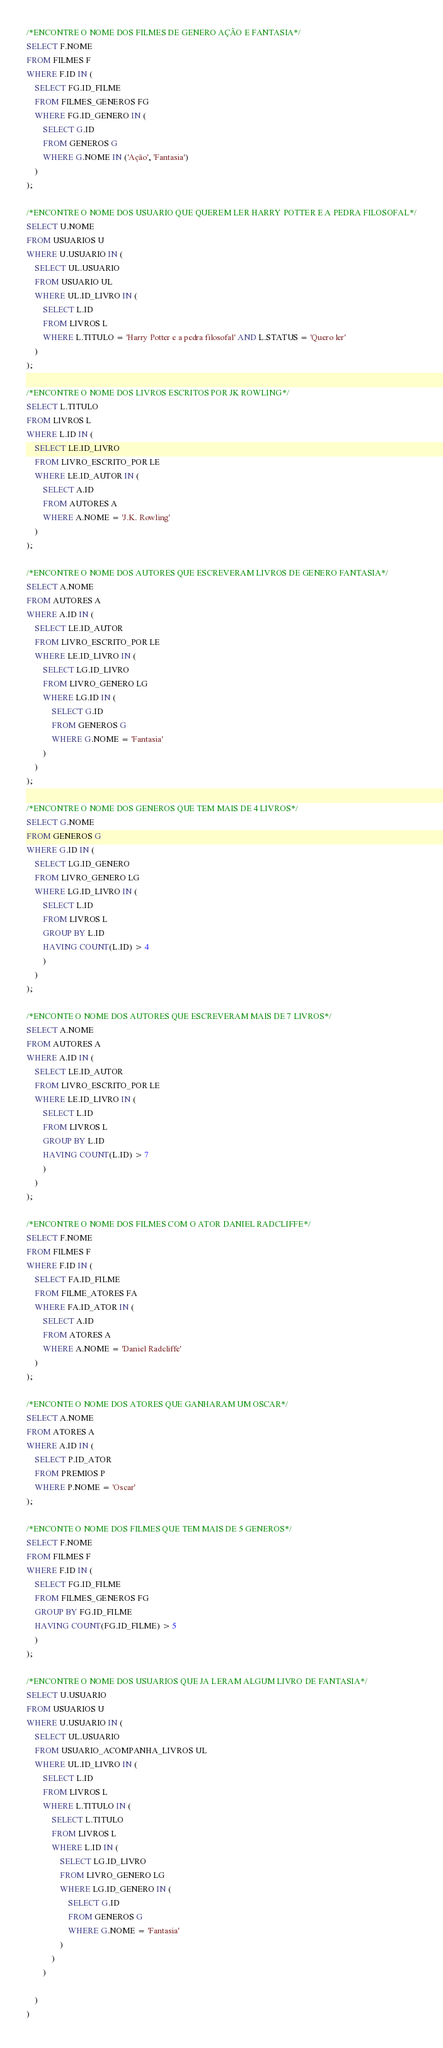Convert code to text. <code><loc_0><loc_0><loc_500><loc_500><_SQL_>/*ENCONTRE O NOME DOS FILMES DE GENERO AÇÃO E FANTASIA*/
SELECT F.NOME
FROM FILMES F
WHERE F.ID IN (
    SELECT FG.ID_FILME
    FROM FILMES_GENEROS FG
    WHERE FG.ID_GENERO IN (
        SELECT G.ID
        FROM GENEROS G
        WHERE G.NOME IN ('Ação', 'Fantasia')
    )
);

/*ENCONTRE O NOME DOS USUARIO QUE QUEREM LER HARRY POTTER E A PEDRA FILOSOFAL*/
SELECT U.NOME
FROM USUARIOS U
WHERE U.USUARIO IN (
    SELECT UL.USUARIO
    FROM USUARIO UL
    WHERE UL.ID_LIVRO IN (
        SELECT L.ID
        FROM LIVROS L
        WHERE L.TITULO = 'Harry Potter e a pedra filosofal' AND L.STATUS = 'Quero ler'
    )
);

/*ENCONTRE O NOME DOS LIVROS ESCRITOS POR JK ROWLING*/
SELECT L.TITULO
FROM LIVROS L
WHERE L.ID IN (
    SELECT LE.ID_LIVRO
    FROM LIVRO_ESCRITO_POR LE
    WHERE LE.ID_AUTOR IN (
        SELECT A.ID
        FROM AUTORES A
        WHERE A.NOME = 'J.K. Rowling'
    )
);

/*ENCONTRE O NOME DOS AUTORES QUE ESCREVERAM LIVROS DE GENERO FANTASIA*/
SELECT A.NOME
FROM AUTORES A
WHERE A.ID IN (
    SELECT LE.ID_AUTOR
    FROM LIVRO_ESCRITO_POR LE
    WHERE LE.ID_LIVRO IN (
        SELECT LG.ID_LIVRO
        FROM LIVRO_GENERO LG
        WHERE LG.ID IN (
            SELECT G.ID
            FROM GENEROS G
            WHERE G.NOME = 'Fantasia'
        )
    )
);

/*ENCONTRE O NOME DOS GENEROS QUE TEM MAIS DE 4 LIVROS*/
SELECT G.NOME
FROM GENEROS G
WHERE G.ID IN (
    SELECT LG.ID_GENERO
    FROM LIVRO_GENERO LG
    WHERE LG.ID_LIVRO IN (
        SELECT L.ID
        FROM LIVROS L
        GROUP BY L.ID
        HAVING COUNT(L.ID) > 4
        )
    )
);

/*ENCONTE O NOME DOS AUTORES QUE ESCREVERAM MAIS DE 7 LIVROS*/
SELECT A.NOME
FROM AUTORES A
WHERE A.ID IN (
    SELECT LE.ID_AUTOR
    FROM LIVRO_ESCRITO_POR LE
    WHERE LE.ID_LIVRO IN (
        SELECT L.ID
        FROM LIVROS L
        GROUP BY L.ID
        HAVING COUNT(L.ID) > 7
        )
    )
);

/*ENCONTRE O NOME DOS FILMES COM O ATOR DANIEL RADCLIFFE*/
SELECT F.NOME
FROM FILMES F
WHERE F.ID IN (
    SELECT FA.ID_FILME
    FROM FILME_ATORES FA
    WHERE FA.ID_ATOR IN (
        SELECT A.ID
        FROM ATORES A
        WHERE A.NOME = 'Daniel Radcliffe'
    )
);

/*ENCONTE O NOME DOS ATORES QUE GANHARAM UM OSCAR*/
SELECT A.NOME
FROM ATORES A
WHERE A.ID IN (
    SELECT P.ID_ATOR
    FROM PREMIOS P
    WHERE P.NOME = 'Oscar'
);

/*ENCONTE O NOME DOS FILMES QUE TEM MAIS DE 5 GENEROS*/
SELECT F.NOME
FROM FILMES F
WHERE F.ID IN (
    SELECT FG.ID_FILME
    FROM FILMES_GENEROS FG
    GROUP BY FG.ID_FILME
    HAVING COUNT(FG.ID_FILME) > 5
    )
);

/*ENCONTRE O NOME DOS USUARIOS QUE JA LERAM ALGUM LIVRO DE FANTASIA*/
SELECT U.USUARIO
FROM USUARIOS U
WHERE U.USUARIO IN (
    SELECT UL.USUARIO
    FROM USUARIO_ACOMPANHA_LIVROS UL
    WHERE UL.ID_LIVRO IN (
        SELECT L.ID
        FROM LIVROS L
        WHERE L.TITULO IN (
            SELECT L.TITULO
            FROM LIVROS L
            WHERE L.ID IN (
                SELECT LG.ID_LIVRO
                FROM LIVRO_GENERO LG
                WHERE LG.ID_GENERO IN (
                    SELECT G.ID
                    FROM GENEROS G
                    WHERE G.NOME = 'Fantasia'
                )
            )
        )
        
    )
)


</code> 